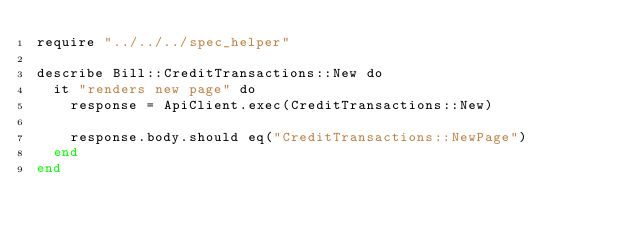Convert code to text. <code><loc_0><loc_0><loc_500><loc_500><_Crystal_>require "../../../spec_helper"

describe Bill::CreditTransactions::New do
  it "renders new page" do
    response = ApiClient.exec(CreditTransactions::New)

    response.body.should eq("CreditTransactions::NewPage")
  end
end
</code> 